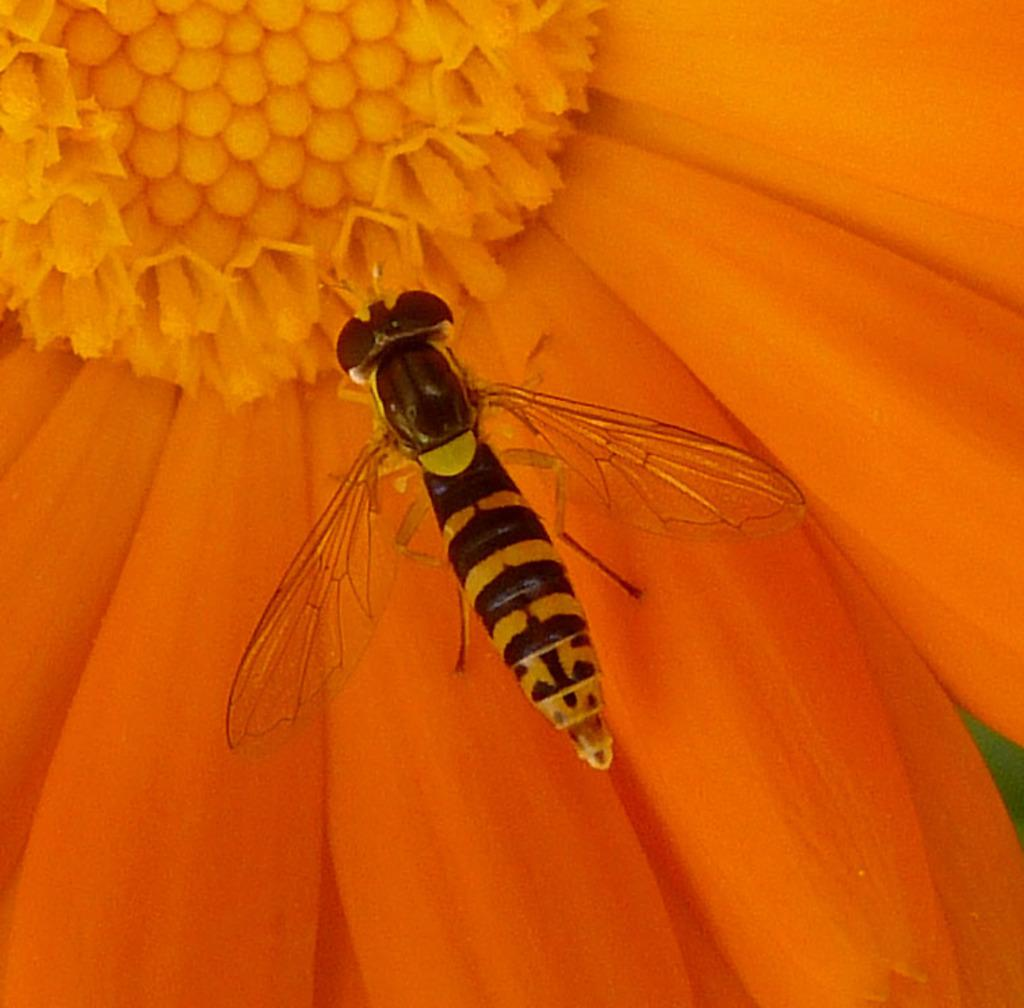What type of insect is in the image? There is a bee in the image. Where is the bee located in the image? The bee is on a flower. What type of quartz can be seen in the image? There is no quartz present in the image; it features a bee on a flower. What joke is being told by the bee in the image? There is no joke being told by the bee in the image; it is simply on a flower. 